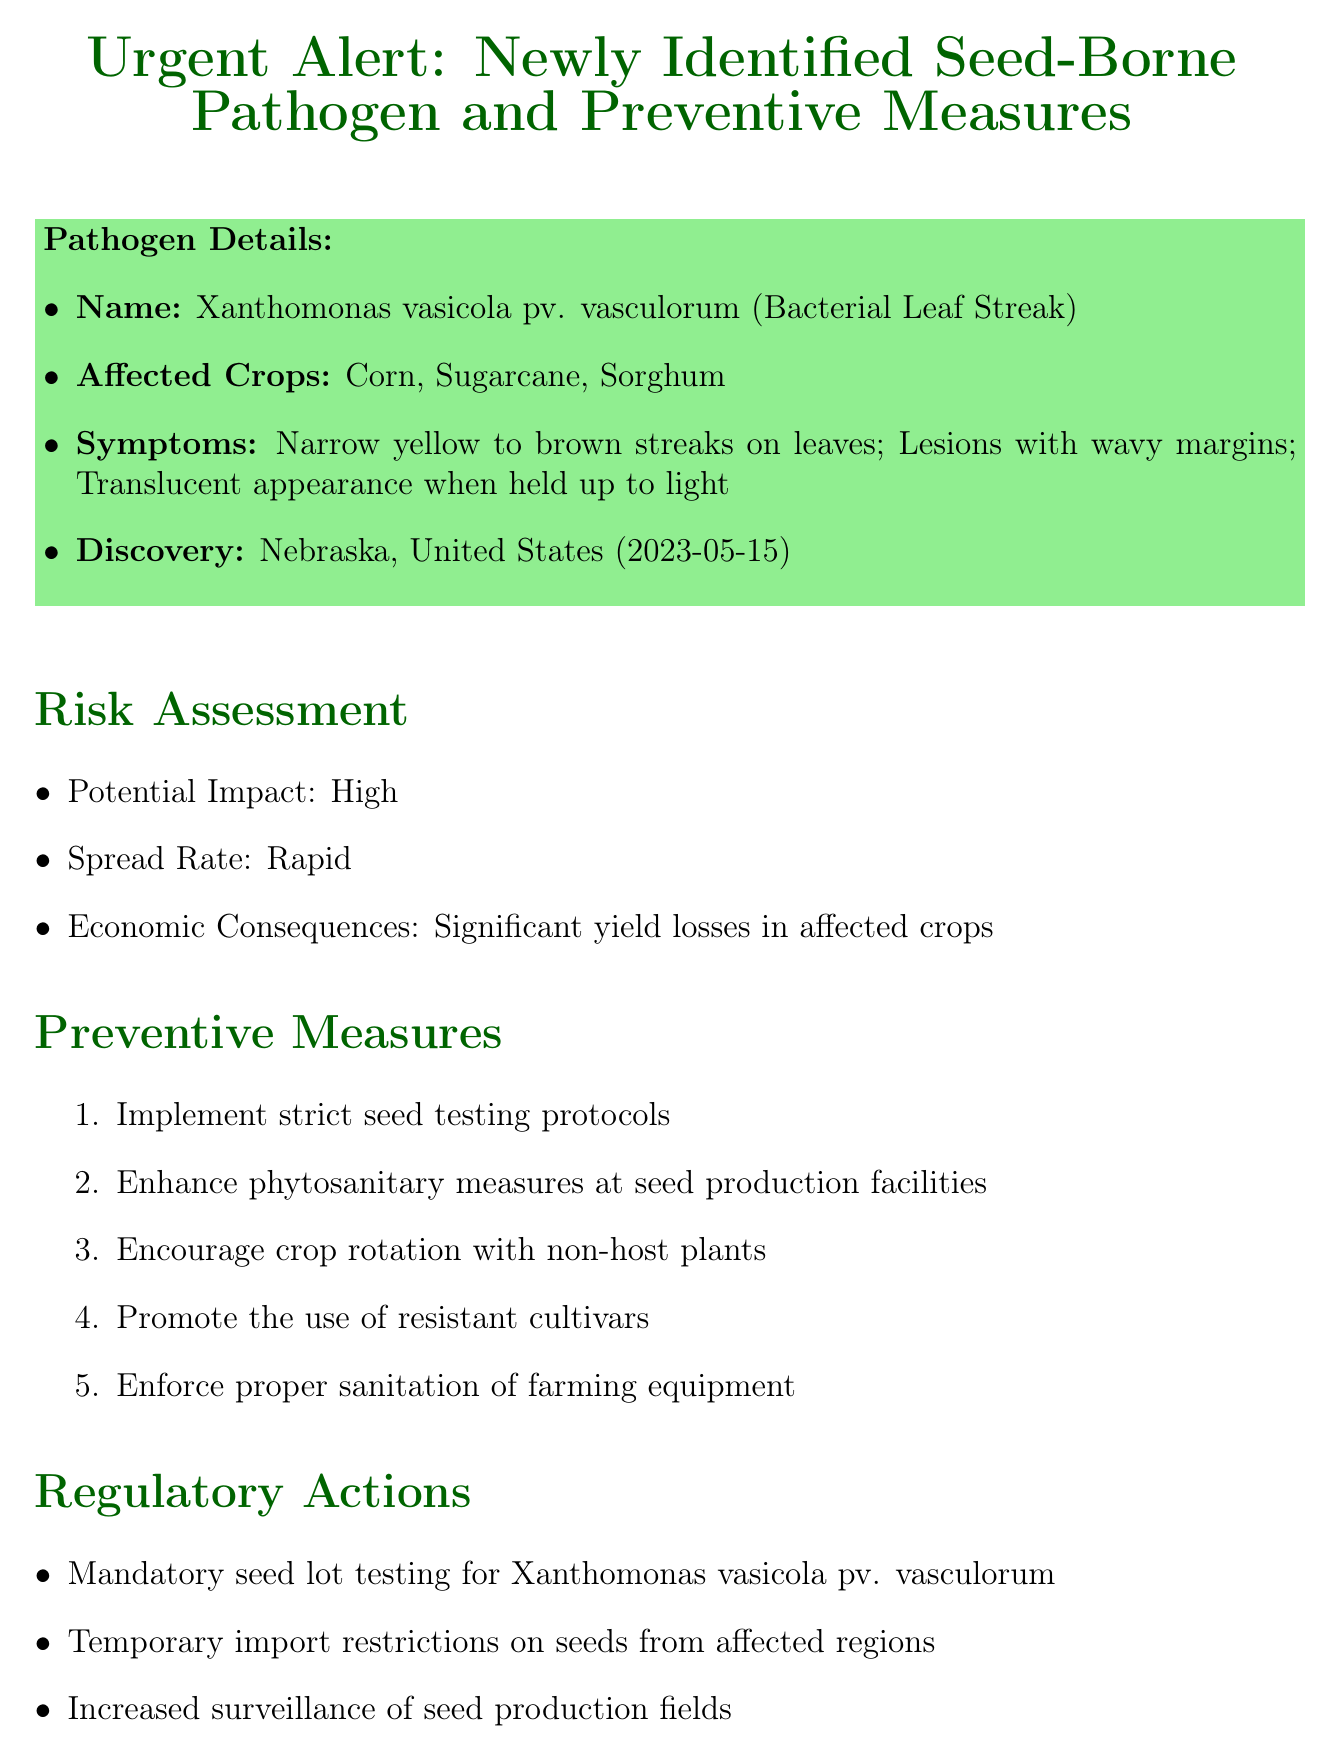what is the name of the newly identified pathogen? The name of the newly identified pathogen is listed under pathogen details in the document.
Answer: Xanthomonas vasicola pv. vasculorum what crops are affected by the pathogen? The affected crops are specified in the pathogen details section of the document.
Answer: Corn, Sugarcane, Sorghum when was the pathogen discovered? The date of discovery is included in the pathogen details section.
Answer: 2023-05-15 what is the potential impact of the pathogen? The potential impact is highlighted in the risk assessment section.
Answer: High what should be done within 30 days according to the action timeline? The action timeline contains specific recommendations for timeframes.
Answer: Conduct training sessions for seed inspectors who issued the memo? The contact information at the end of the document specifies the person responsible.
Answer: Dr. Sarah Johnson what should seed producers do to comply with the regulations? Compliance requirements are detailed in the regulatory actions section of the document.
Answer: Mandatory seed lot testing for Xanthomonas vasicola pv. vasculorum how can stakeholders get more information? The resources section provides contact information for assistance.
Answer: +1-800-SEED-HELP what are the symptoms of the pathogen? The symptoms are listed in the pathogen details section.
Answer: Narrow, yellow to brown streaks on leaves; Lesions with wavy margins; Translucent appearance when held up to light 